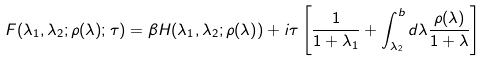<formula> <loc_0><loc_0><loc_500><loc_500>F ( \lambda _ { 1 } , \lambda _ { 2 } ; \rho ( \lambda ) ; \tau ) = \beta H ( \lambda _ { 1 } , \lambda _ { 2 } ; { \rho ( \lambda ) } ) + i \tau \left [ \frac { 1 } { 1 + \lambda _ { 1 } } + \int _ { \lambda _ { 2 } } ^ { b } d \lambda \frac { \rho ( \lambda ) } { 1 + \lambda } \right ]</formula> 